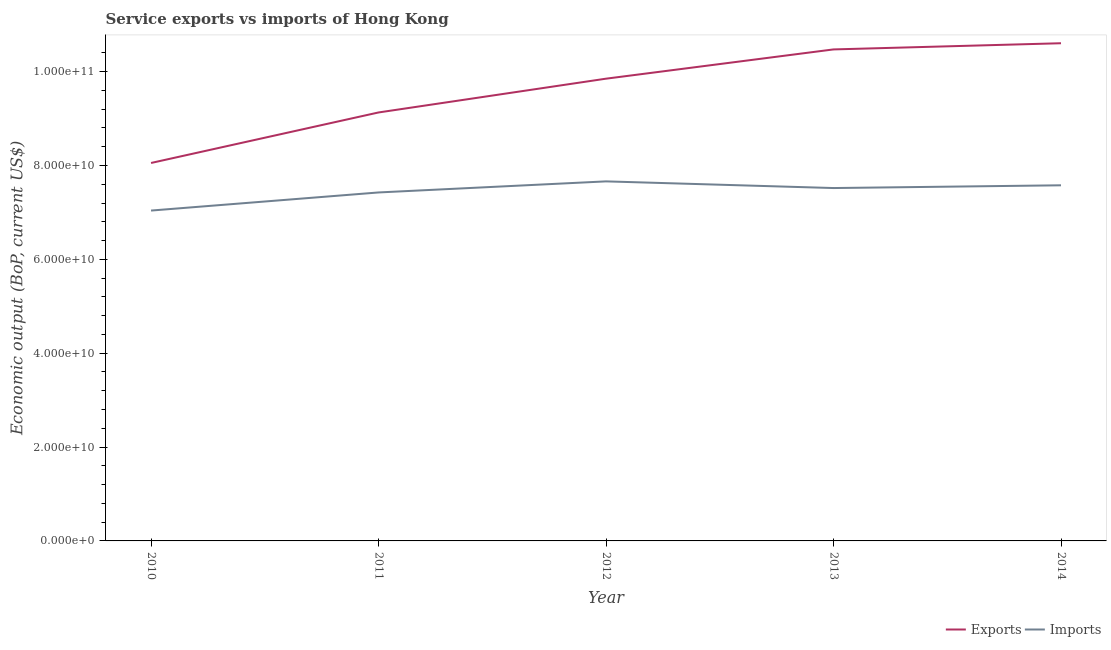How many different coloured lines are there?
Keep it short and to the point. 2. Is the number of lines equal to the number of legend labels?
Your answer should be very brief. Yes. What is the amount of service exports in 2011?
Offer a terse response. 9.13e+1. Across all years, what is the maximum amount of service imports?
Keep it short and to the point. 7.66e+1. Across all years, what is the minimum amount of service imports?
Your answer should be compact. 7.04e+1. What is the total amount of service exports in the graph?
Your answer should be very brief. 4.81e+11. What is the difference between the amount of service exports in 2012 and that in 2014?
Provide a succinct answer. -7.55e+09. What is the difference between the amount of service exports in 2014 and the amount of service imports in 2012?
Provide a succinct answer. 2.94e+1. What is the average amount of service imports per year?
Offer a very short reply. 7.45e+1. In the year 2014, what is the difference between the amount of service exports and amount of service imports?
Your answer should be very brief. 3.03e+1. In how many years, is the amount of service imports greater than 56000000000 US$?
Provide a short and direct response. 5. What is the ratio of the amount of service exports in 2010 to that in 2011?
Provide a short and direct response. 0.88. Is the amount of service imports in 2011 less than that in 2012?
Give a very brief answer. Yes. Is the difference between the amount of service imports in 2010 and 2013 greater than the difference between the amount of service exports in 2010 and 2013?
Keep it short and to the point. Yes. What is the difference between the highest and the second highest amount of service exports?
Make the answer very short. 1.32e+09. What is the difference between the highest and the lowest amount of service imports?
Your response must be concise. 6.22e+09. Is the amount of service imports strictly greater than the amount of service exports over the years?
Offer a very short reply. No. How many years are there in the graph?
Offer a terse response. 5. What is the difference between two consecutive major ticks on the Y-axis?
Give a very brief answer. 2.00e+1. Are the values on the major ticks of Y-axis written in scientific E-notation?
Your answer should be compact. Yes. Does the graph contain any zero values?
Keep it short and to the point. No. Does the graph contain grids?
Provide a short and direct response. No. Where does the legend appear in the graph?
Your answer should be compact. Bottom right. How many legend labels are there?
Provide a succinct answer. 2. What is the title of the graph?
Give a very brief answer. Service exports vs imports of Hong Kong. What is the label or title of the X-axis?
Your response must be concise. Year. What is the label or title of the Y-axis?
Ensure brevity in your answer.  Economic output (BoP, current US$). What is the Economic output (BoP, current US$) in Exports in 2010?
Offer a terse response. 8.05e+1. What is the Economic output (BoP, current US$) in Imports in 2010?
Your answer should be compact. 7.04e+1. What is the Economic output (BoP, current US$) in Exports in 2011?
Make the answer very short. 9.13e+1. What is the Economic output (BoP, current US$) of Imports in 2011?
Keep it short and to the point. 7.43e+1. What is the Economic output (BoP, current US$) in Exports in 2012?
Your response must be concise. 9.85e+1. What is the Economic output (BoP, current US$) of Imports in 2012?
Offer a very short reply. 7.66e+1. What is the Economic output (BoP, current US$) of Exports in 2013?
Ensure brevity in your answer.  1.05e+11. What is the Economic output (BoP, current US$) in Imports in 2013?
Provide a succinct answer. 7.52e+1. What is the Economic output (BoP, current US$) in Exports in 2014?
Your response must be concise. 1.06e+11. What is the Economic output (BoP, current US$) in Imports in 2014?
Give a very brief answer. 7.58e+1. Across all years, what is the maximum Economic output (BoP, current US$) in Exports?
Offer a very short reply. 1.06e+11. Across all years, what is the maximum Economic output (BoP, current US$) in Imports?
Your response must be concise. 7.66e+1. Across all years, what is the minimum Economic output (BoP, current US$) in Exports?
Your response must be concise. 8.05e+1. Across all years, what is the minimum Economic output (BoP, current US$) of Imports?
Keep it short and to the point. 7.04e+1. What is the total Economic output (BoP, current US$) of Exports in the graph?
Your response must be concise. 4.81e+11. What is the total Economic output (BoP, current US$) in Imports in the graph?
Offer a terse response. 3.72e+11. What is the difference between the Economic output (BoP, current US$) of Exports in 2010 and that in 2011?
Provide a succinct answer. -1.08e+1. What is the difference between the Economic output (BoP, current US$) of Imports in 2010 and that in 2011?
Provide a short and direct response. -3.86e+09. What is the difference between the Economic output (BoP, current US$) in Exports in 2010 and that in 2012?
Keep it short and to the point. -1.80e+1. What is the difference between the Economic output (BoP, current US$) of Imports in 2010 and that in 2012?
Provide a short and direct response. -6.22e+09. What is the difference between the Economic output (BoP, current US$) in Exports in 2010 and that in 2013?
Provide a succinct answer. -2.42e+1. What is the difference between the Economic output (BoP, current US$) of Imports in 2010 and that in 2013?
Make the answer very short. -4.80e+09. What is the difference between the Economic output (BoP, current US$) in Exports in 2010 and that in 2014?
Ensure brevity in your answer.  -2.55e+1. What is the difference between the Economic output (BoP, current US$) in Imports in 2010 and that in 2014?
Your answer should be compact. -5.39e+09. What is the difference between the Economic output (BoP, current US$) in Exports in 2011 and that in 2012?
Your answer should be very brief. -7.20e+09. What is the difference between the Economic output (BoP, current US$) in Imports in 2011 and that in 2012?
Your response must be concise. -2.36e+09. What is the difference between the Economic output (BoP, current US$) of Exports in 2011 and that in 2013?
Your answer should be very brief. -1.34e+1. What is the difference between the Economic output (BoP, current US$) of Imports in 2011 and that in 2013?
Your response must be concise. -9.38e+08. What is the difference between the Economic output (BoP, current US$) in Exports in 2011 and that in 2014?
Your response must be concise. -1.48e+1. What is the difference between the Economic output (BoP, current US$) of Imports in 2011 and that in 2014?
Make the answer very short. -1.53e+09. What is the difference between the Economic output (BoP, current US$) of Exports in 2012 and that in 2013?
Your response must be concise. -6.23e+09. What is the difference between the Economic output (BoP, current US$) in Imports in 2012 and that in 2013?
Ensure brevity in your answer.  1.42e+09. What is the difference between the Economic output (BoP, current US$) in Exports in 2012 and that in 2014?
Keep it short and to the point. -7.55e+09. What is the difference between the Economic output (BoP, current US$) in Imports in 2012 and that in 2014?
Your response must be concise. 8.34e+08. What is the difference between the Economic output (BoP, current US$) of Exports in 2013 and that in 2014?
Offer a very short reply. -1.32e+09. What is the difference between the Economic output (BoP, current US$) of Imports in 2013 and that in 2014?
Provide a short and direct response. -5.87e+08. What is the difference between the Economic output (BoP, current US$) of Exports in 2010 and the Economic output (BoP, current US$) of Imports in 2011?
Keep it short and to the point. 6.28e+09. What is the difference between the Economic output (BoP, current US$) of Exports in 2010 and the Economic output (BoP, current US$) of Imports in 2012?
Your answer should be compact. 3.92e+09. What is the difference between the Economic output (BoP, current US$) in Exports in 2010 and the Economic output (BoP, current US$) in Imports in 2013?
Offer a very short reply. 5.34e+09. What is the difference between the Economic output (BoP, current US$) in Exports in 2010 and the Economic output (BoP, current US$) in Imports in 2014?
Make the answer very short. 4.76e+09. What is the difference between the Economic output (BoP, current US$) of Exports in 2011 and the Economic output (BoP, current US$) of Imports in 2012?
Your response must be concise. 1.47e+1. What is the difference between the Economic output (BoP, current US$) in Exports in 2011 and the Economic output (BoP, current US$) in Imports in 2013?
Ensure brevity in your answer.  1.61e+1. What is the difference between the Economic output (BoP, current US$) in Exports in 2011 and the Economic output (BoP, current US$) in Imports in 2014?
Offer a very short reply. 1.55e+1. What is the difference between the Economic output (BoP, current US$) of Exports in 2012 and the Economic output (BoP, current US$) of Imports in 2013?
Give a very brief answer. 2.33e+1. What is the difference between the Economic output (BoP, current US$) in Exports in 2012 and the Economic output (BoP, current US$) in Imports in 2014?
Your answer should be very brief. 2.27e+1. What is the difference between the Economic output (BoP, current US$) of Exports in 2013 and the Economic output (BoP, current US$) of Imports in 2014?
Offer a very short reply. 2.90e+1. What is the average Economic output (BoP, current US$) in Exports per year?
Your answer should be very brief. 9.62e+1. What is the average Economic output (BoP, current US$) in Imports per year?
Ensure brevity in your answer.  7.45e+1. In the year 2010, what is the difference between the Economic output (BoP, current US$) of Exports and Economic output (BoP, current US$) of Imports?
Keep it short and to the point. 1.01e+1. In the year 2011, what is the difference between the Economic output (BoP, current US$) of Exports and Economic output (BoP, current US$) of Imports?
Provide a short and direct response. 1.70e+1. In the year 2012, what is the difference between the Economic output (BoP, current US$) of Exports and Economic output (BoP, current US$) of Imports?
Your answer should be very brief. 2.19e+1. In the year 2013, what is the difference between the Economic output (BoP, current US$) in Exports and Economic output (BoP, current US$) in Imports?
Provide a succinct answer. 2.95e+1. In the year 2014, what is the difference between the Economic output (BoP, current US$) in Exports and Economic output (BoP, current US$) in Imports?
Make the answer very short. 3.03e+1. What is the ratio of the Economic output (BoP, current US$) of Exports in 2010 to that in 2011?
Your answer should be very brief. 0.88. What is the ratio of the Economic output (BoP, current US$) of Imports in 2010 to that in 2011?
Offer a very short reply. 0.95. What is the ratio of the Economic output (BoP, current US$) of Exports in 2010 to that in 2012?
Your answer should be very brief. 0.82. What is the ratio of the Economic output (BoP, current US$) in Imports in 2010 to that in 2012?
Offer a very short reply. 0.92. What is the ratio of the Economic output (BoP, current US$) of Exports in 2010 to that in 2013?
Make the answer very short. 0.77. What is the ratio of the Economic output (BoP, current US$) of Imports in 2010 to that in 2013?
Your answer should be compact. 0.94. What is the ratio of the Economic output (BoP, current US$) in Exports in 2010 to that in 2014?
Ensure brevity in your answer.  0.76. What is the ratio of the Economic output (BoP, current US$) in Imports in 2010 to that in 2014?
Make the answer very short. 0.93. What is the ratio of the Economic output (BoP, current US$) of Exports in 2011 to that in 2012?
Provide a succinct answer. 0.93. What is the ratio of the Economic output (BoP, current US$) of Imports in 2011 to that in 2012?
Provide a short and direct response. 0.97. What is the ratio of the Economic output (BoP, current US$) in Exports in 2011 to that in 2013?
Your answer should be compact. 0.87. What is the ratio of the Economic output (BoP, current US$) of Imports in 2011 to that in 2013?
Your answer should be compact. 0.99. What is the ratio of the Economic output (BoP, current US$) of Exports in 2011 to that in 2014?
Your response must be concise. 0.86. What is the ratio of the Economic output (BoP, current US$) of Imports in 2011 to that in 2014?
Keep it short and to the point. 0.98. What is the ratio of the Economic output (BoP, current US$) in Exports in 2012 to that in 2013?
Your response must be concise. 0.94. What is the ratio of the Economic output (BoP, current US$) of Imports in 2012 to that in 2013?
Provide a succinct answer. 1.02. What is the ratio of the Economic output (BoP, current US$) in Exports in 2012 to that in 2014?
Keep it short and to the point. 0.93. What is the ratio of the Economic output (BoP, current US$) in Exports in 2013 to that in 2014?
Give a very brief answer. 0.99. What is the ratio of the Economic output (BoP, current US$) of Imports in 2013 to that in 2014?
Ensure brevity in your answer.  0.99. What is the difference between the highest and the second highest Economic output (BoP, current US$) in Exports?
Your answer should be compact. 1.32e+09. What is the difference between the highest and the second highest Economic output (BoP, current US$) of Imports?
Make the answer very short. 8.34e+08. What is the difference between the highest and the lowest Economic output (BoP, current US$) of Exports?
Give a very brief answer. 2.55e+1. What is the difference between the highest and the lowest Economic output (BoP, current US$) in Imports?
Offer a terse response. 6.22e+09. 